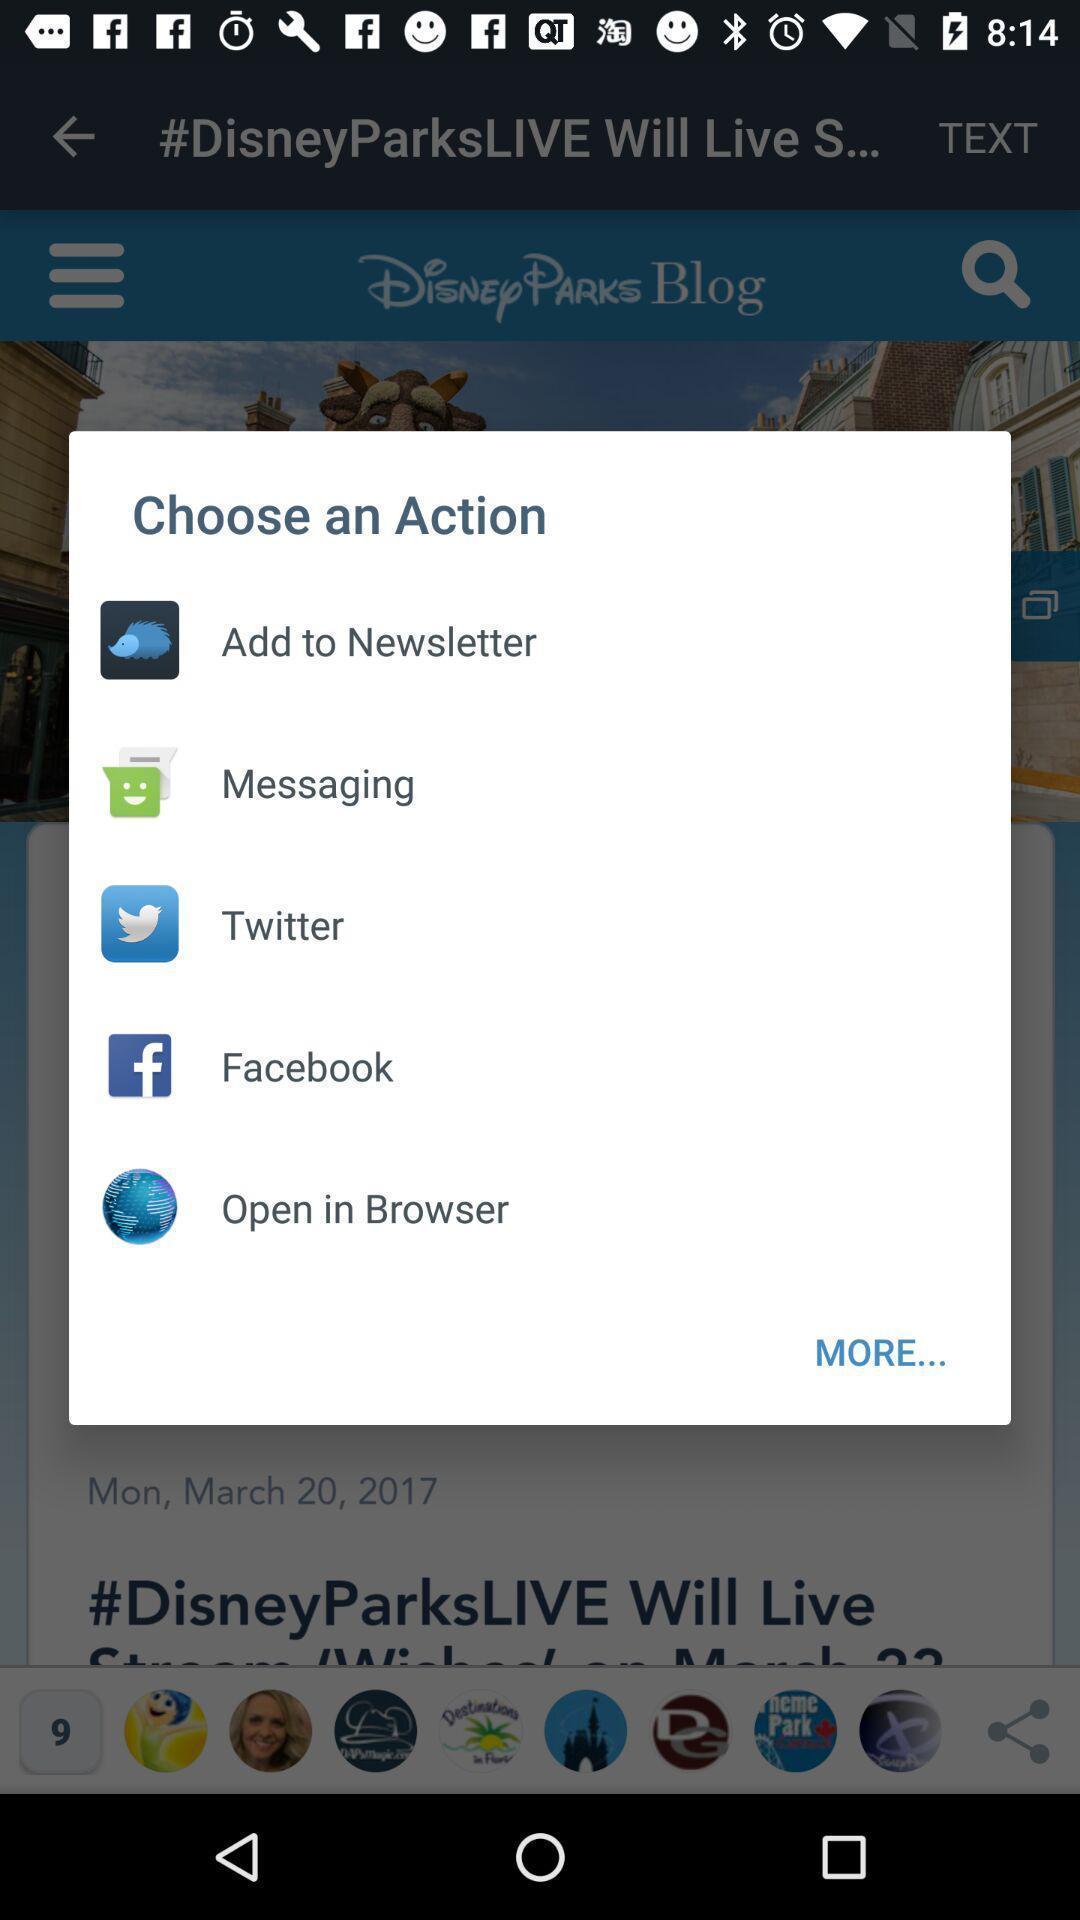Provide a textual representation of this image. Pop-up asking to choose an action. 